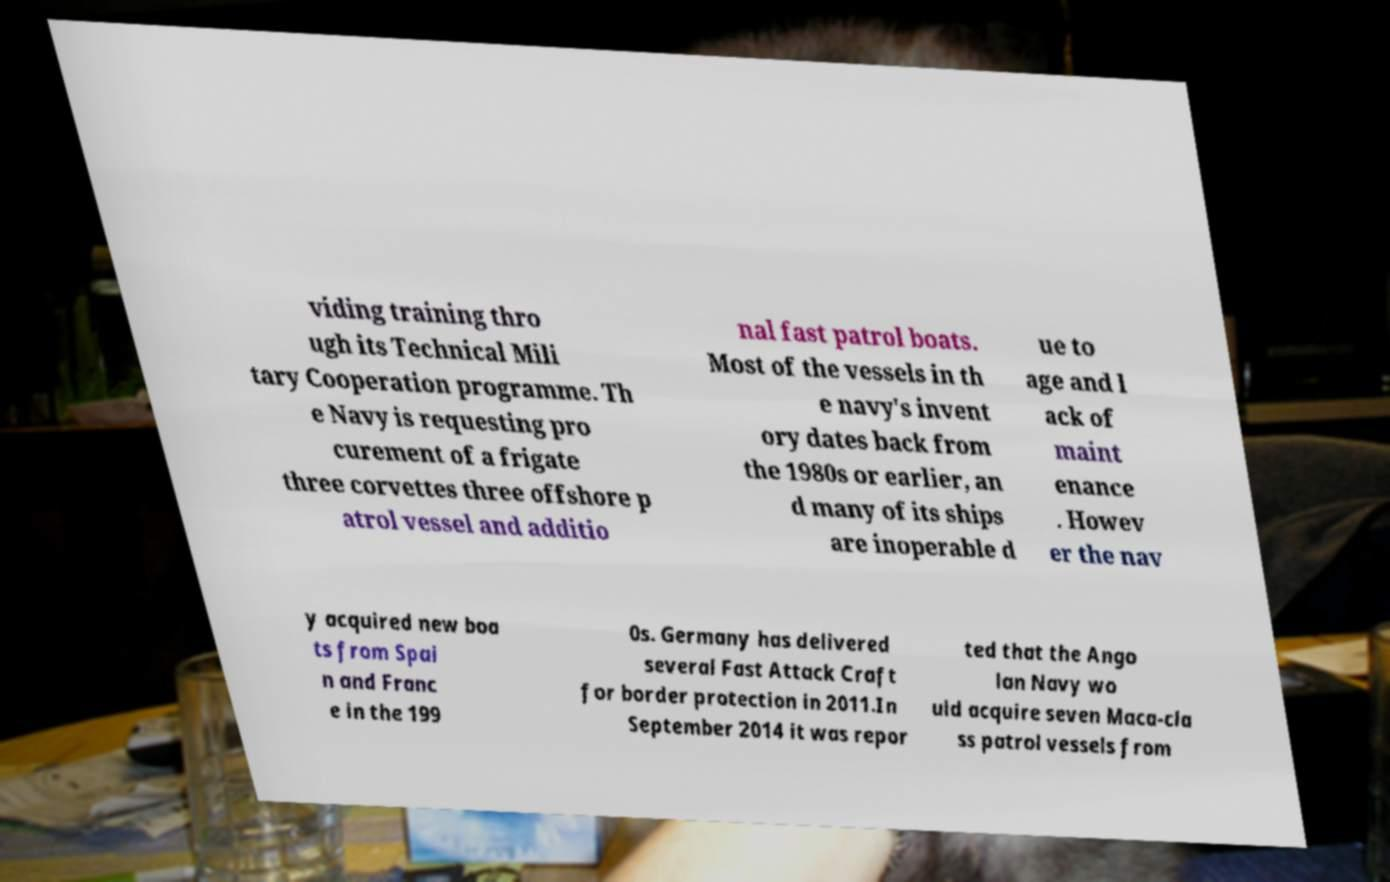Could you assist in decoding the text presented in this image and type it out clearly? viding training thro ugh its Technical Mili tary Cooperation programme. Th e Navy is requesting pro curement of a frigate three corvettes three offshore p atrol vessel and additio nal fast patrol boats. Most of the vessels in th e navy's invent ory dates back from the 1980s or earlier, an d many of its ships are inoperable d ue to age and l ack of maint enance . Howev er the nav y acquired new boa ts from Spai n and Franc e in the 199 0s. Germany has delivered several Fast Attack Craft for border protection in 2011.In September 2014 it was repor ted that the Ango lan Navy wo uld acquire seven Maca-cla ss patrol vessels from 